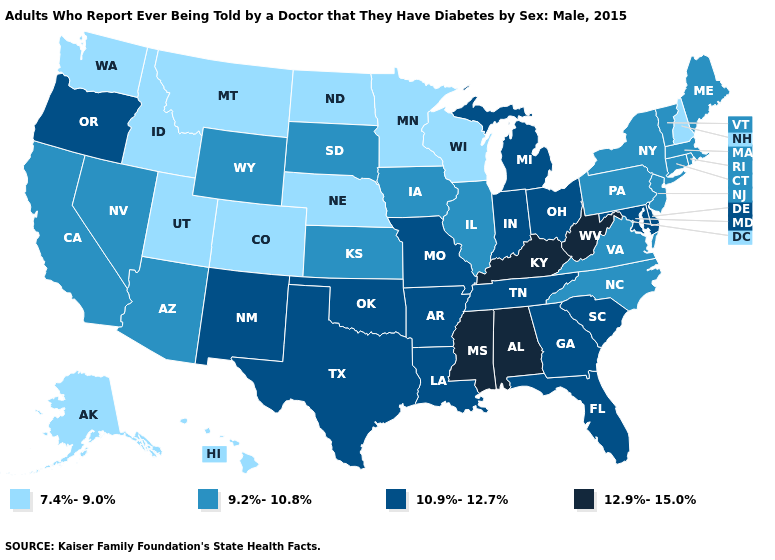Name the states that have a value in the range 10.9%-12.7%?
Answer briefly. Arkansas, Delaware, Florida, Georgia, Indiana, Louisiana, Maryland, Michigan, Missouri, New Mexico, Ohio, Oklahoma, Oregon, South Carolina, Tennessee, Texas. What is the lowest value in states that border New York?
Short answer required. 9.2%-10.8%. What is the value of Alabama?
Answer briefly. 12.9%-15.0%. Name the states that have a value in the range 12.9%-15.0%?
Write a very short answer. Alabama, Kentucky, Mississippi, West Virginia. What is the value of New Mexico?
Answer briefly. 10.9%-12.7%. Name the states that have a value in the range 12.9%-15.0%?
Write a very short answer. Alabama, Kentucky, Mississippi, West Virginia. What is the value of South Dakota?
Give a very brief answer. 9.2%-10.8%. Does Vermont have the same value as Illinois?
Write a very short answer. Yes. How many symbols are there in the legend?
Give a very brief answer. 4. Among the states that border New York , which have the lowest value?
Quick response, please. Connecticut, Massachusetts, New Jersey, Pennsylvania, Vermont. Which states have the lowest value in the USA?
Write a very short answer. Alaska, Colorado, Hawaii, Idaho, Minnesota, Montana, Nebraska, New Hampshire, North Dakota, Utah, Washington, Wisconsin. Which states have the lowest value in the South?
Give a very brief answer. North Carolina, Virginia. Among the states that border Ohio , does Indiana have the lowest value?
Short answer required. No. Does Delaware have a higher value than New Mexico?
Be succinct. No. Name the states that have a value in the range 7.4%-9.0%?
Concise answer only. Alaska, Colorado, Hawaii, Idaho, Minnesota, Montana, Nebraska, New Hampshire, North Dakota, Utah, Washington, Wisconsin. 